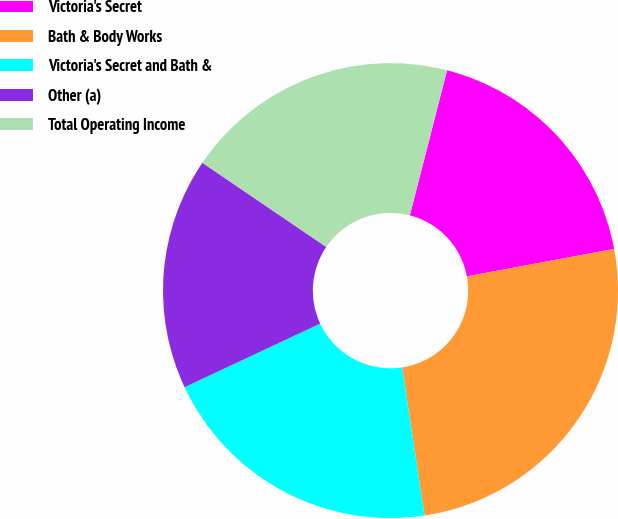Convert chart to OTSL. <chart><loc_0><loc_0><loc_500><loc_500><pie_chart><fcel>Victoria's Secret<fcel>Bath & Body Works<fcel>Victoria's Secret and Bath &<fcel>Other (a)<fcel>Total Operating Income<nl><fcel>18.07%<fcel>25.55%<fcel>20.41%<fcel>16.48%<fcel>19.5%<nl></chart> 